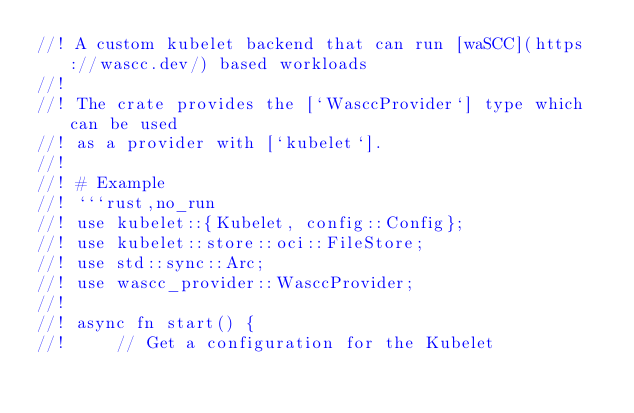Convert code to text. <code><loc_0><loc_0><loc_500><loc_500><_Rust_>//! A custom kubelet backend that can run [waSCC](https://wascc.dev/) based workloads
//!
//! The crate provides the [`WasccProvider`] type which can be used
//! as a provider with [`kubelet`].
//!
//! # Example
//! ```rust,no_run
//! use kubelet::{Kubelet, config::Config};
//! use kubelet::store::oci::FileStore;
//! use std::sync::Arc;
//! use wascc_provider::WasccProvider;
//!
//! async fn start() {
//!     // Get a configuration for the Kubelet</code> 